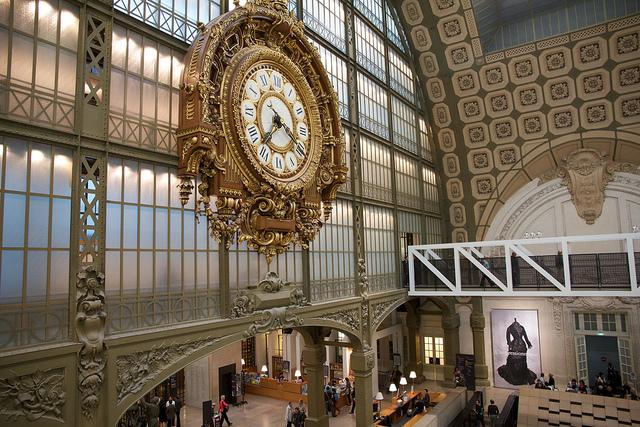What is on the advertisement overlooked by the gold clock? dress 